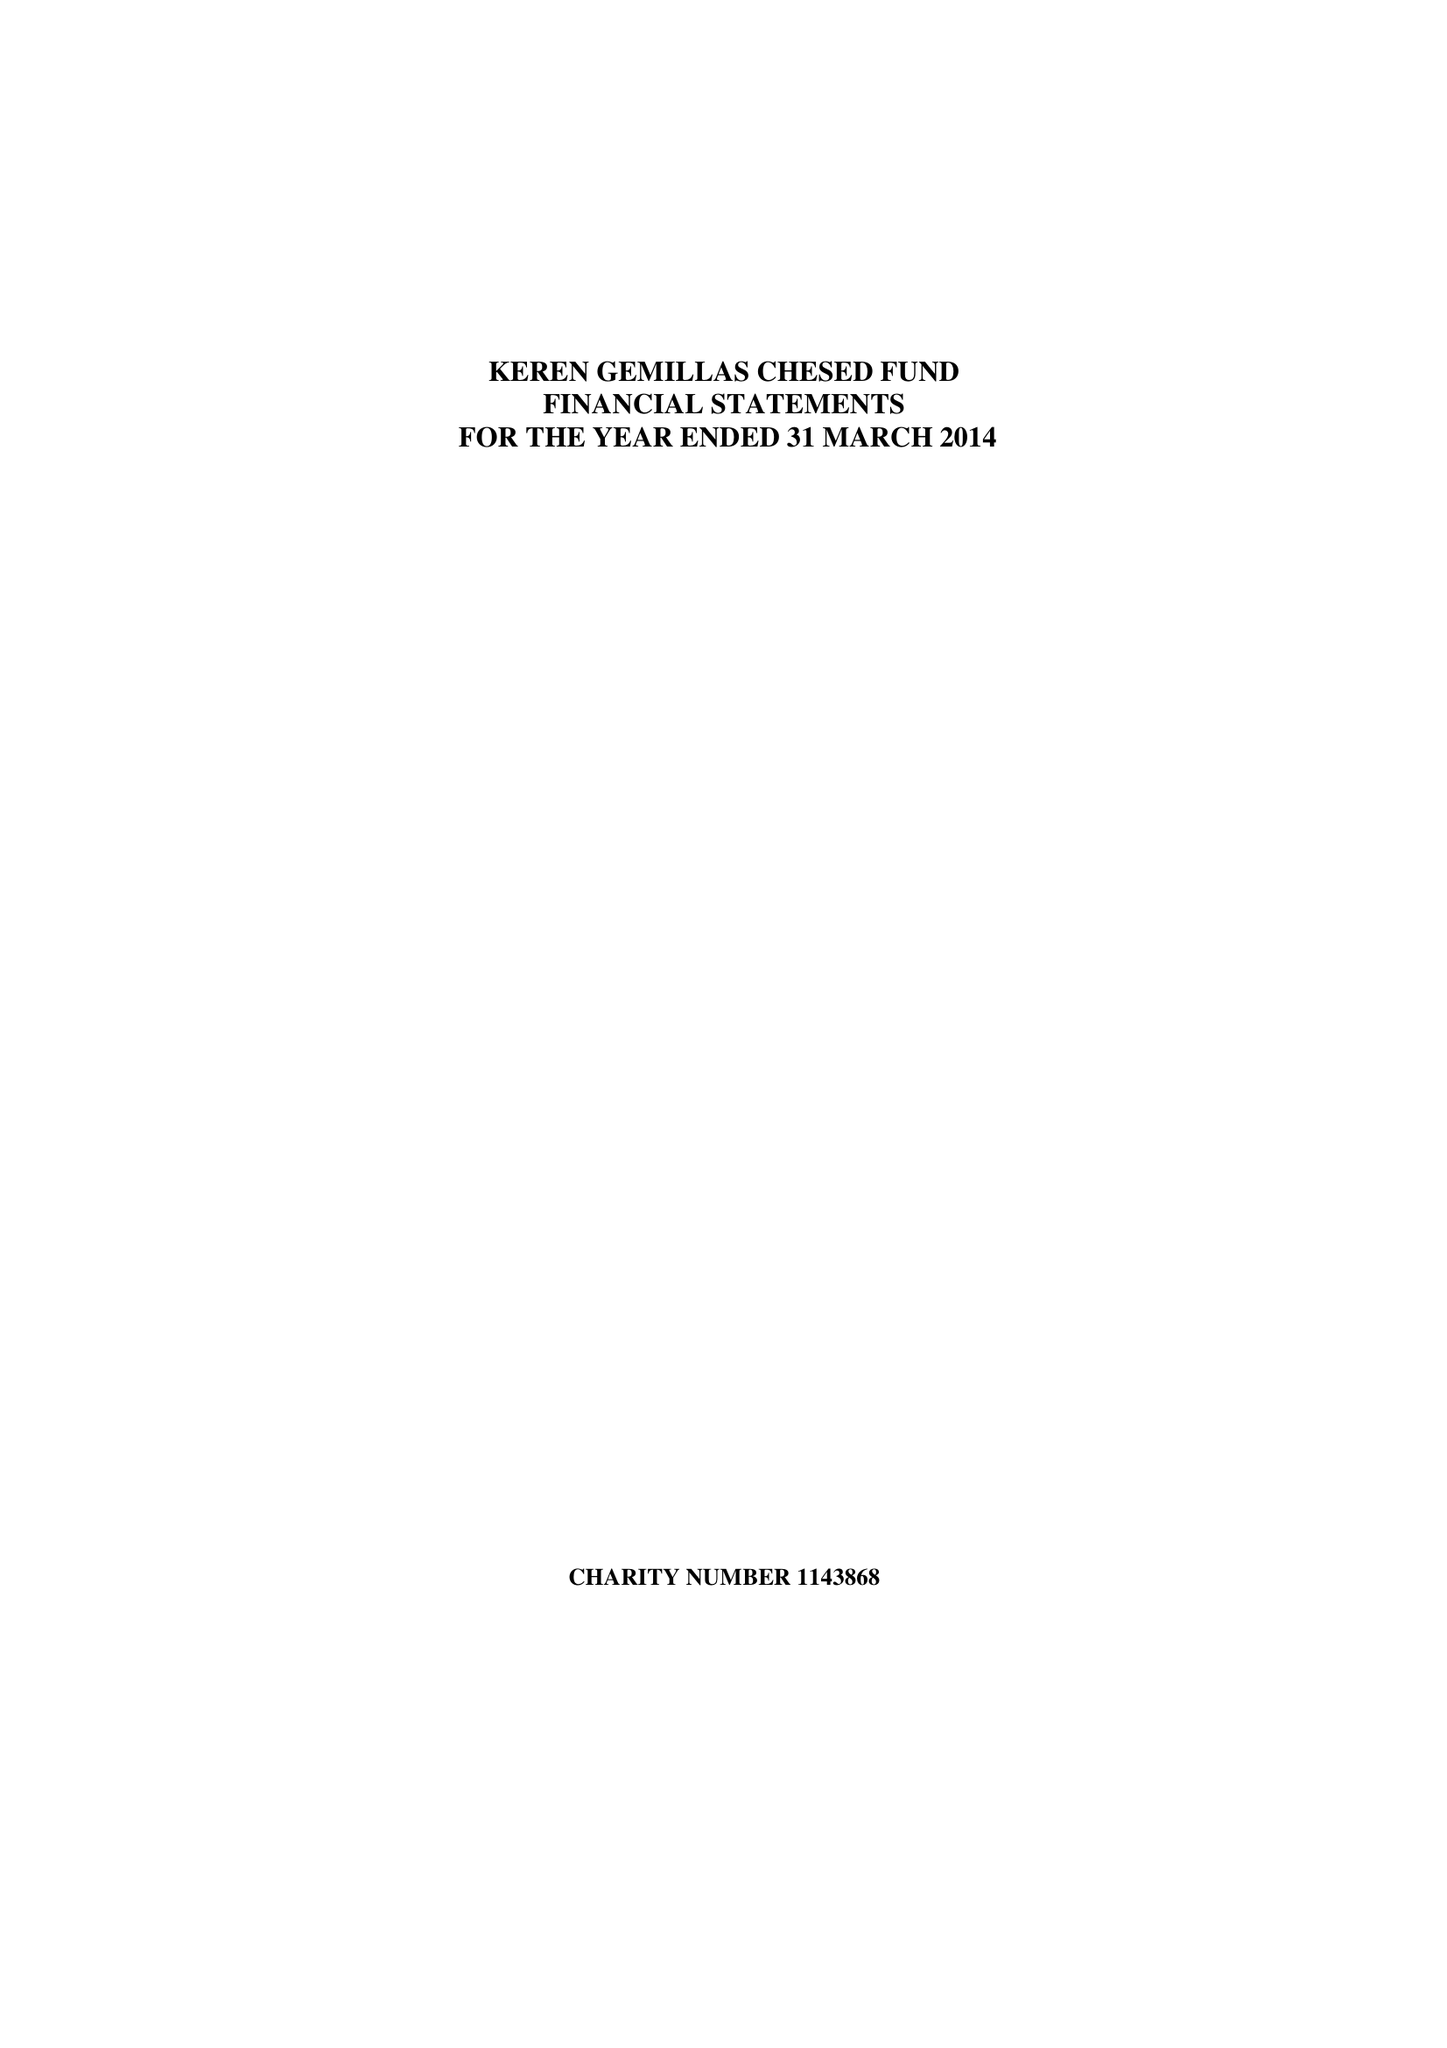What is the value for the charity_name?
Answer the question using a single word or phrase. Keren Gemillas Chesed Fund 